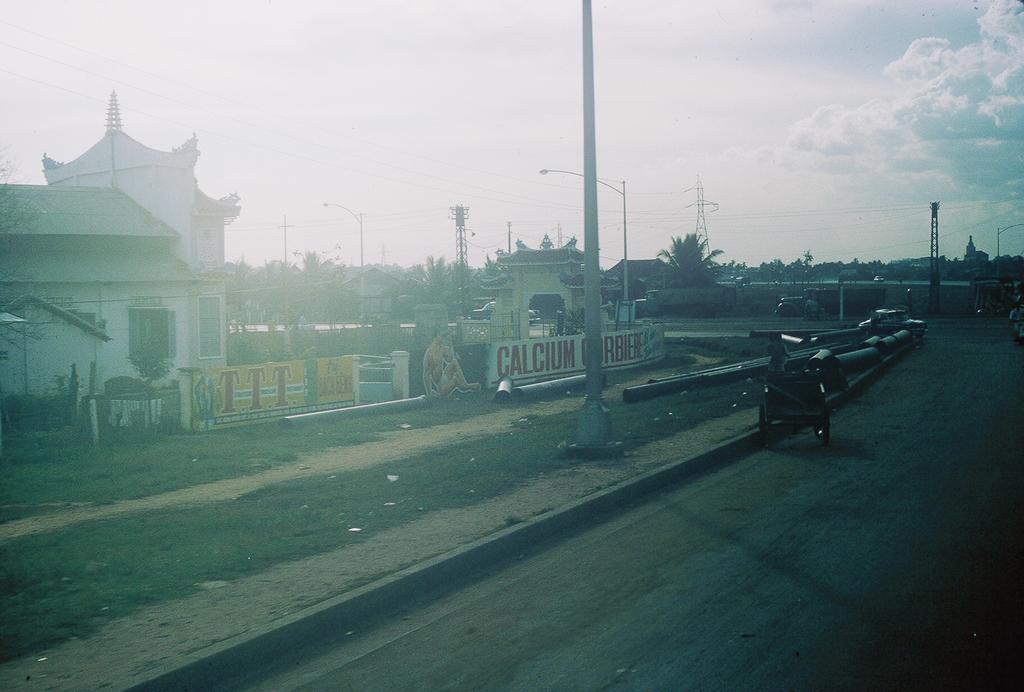Please provide a concise description of this image. In this image, we can see houses, poles, towers, trees, walls, windows, grass. At the bottom, there is a road. Few vehicles are on the road. Background there is a sky. 